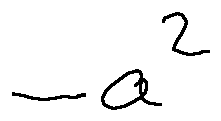Convert formula to latex. <formula><loc_0><loc_0><loc_500><loc_500>- a ^ { 2 }</formula> 